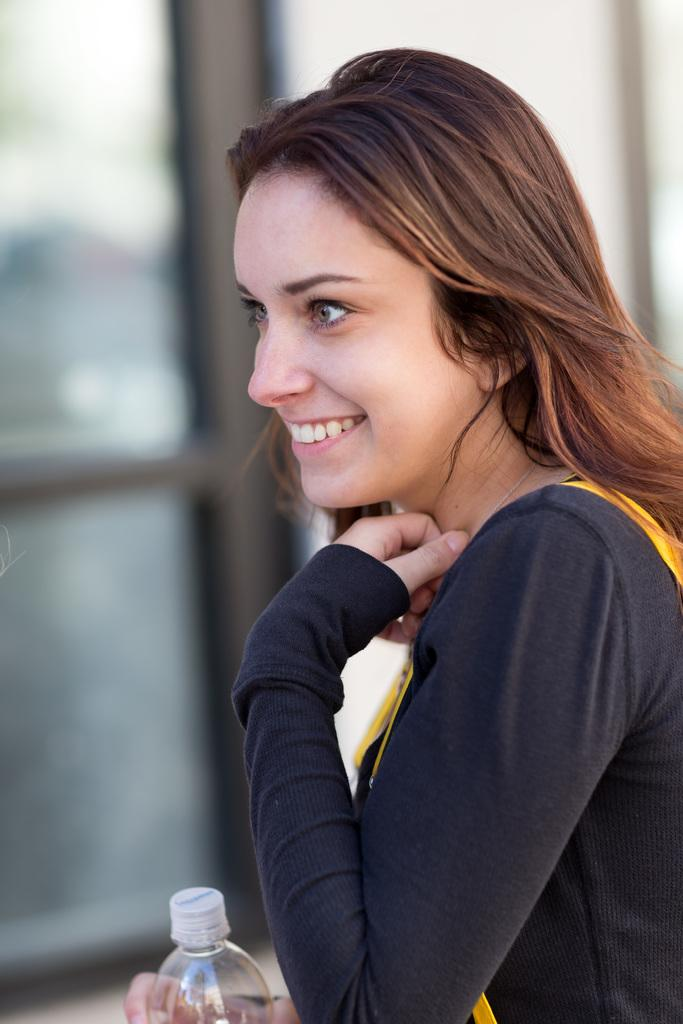Who is the main subject in the image? There is a woman in the image. What is the woman wearing? The woman is wearing a black shirt. What is the woman holding in the image? The woman is holding a bottle. Can you describe the background of the image? The background of the image is blurry. What type of question can be seen on the bridge in the image? There is no bridge present in the image, and therefore no question can be seen on it. 